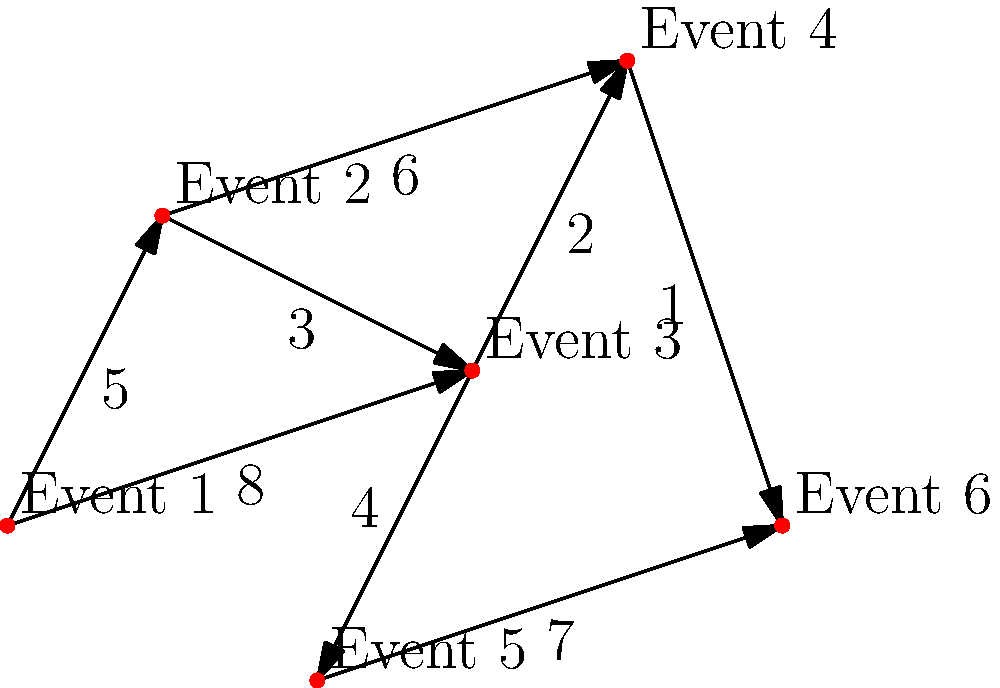In a rodeo arena, six different events are connected by paths as shown in the diagram. The numbers on the paths represent the time (in minutes) it takes to move between events. What is the shortest time required to travel from Event 1 to Event 6? To find the shortest path from Event 1 to Event 6, we'll use Dijkstra's algorithm:

1. Initialize:
   - Distance to Event 1: 0
   - Distance to all other events: $\infty$

2. Start at Event 1:
   - Update neighbors:
     Event 2: min($\infty$, 0 + 5) = 5
     Event 3: min($\infty$, 0 + 8) = 8

3. Move to Event 2 (closest unvisited):
   - Update neighbors:
     Event 3: min(8, 5 + 3) = 8
     Event 4: min($\infty$, 5 + 6) = 11

4. Move to Event 3:
   - Update neighbors:
     Event 4: min(11, 8 + 2) = 10
     Event 5: min($\infty$, 8 + 4) = 12

5. Move to Event 4:
   - Update neighbors:
     Event 6: min($\infty$, 10 + 1) = 11

6. Move to Event 5:
   - Update neighbors:
     Event 6: min(11, 12 + 7) = 11

7. Move to Event 6:
   - All events visited, algorithm terminates

The shortest path is Event 1 → Event 2 → Event 3 → Event 4 → Event 6, with a total time of 11 minutes.
Answer: 11 minutes 